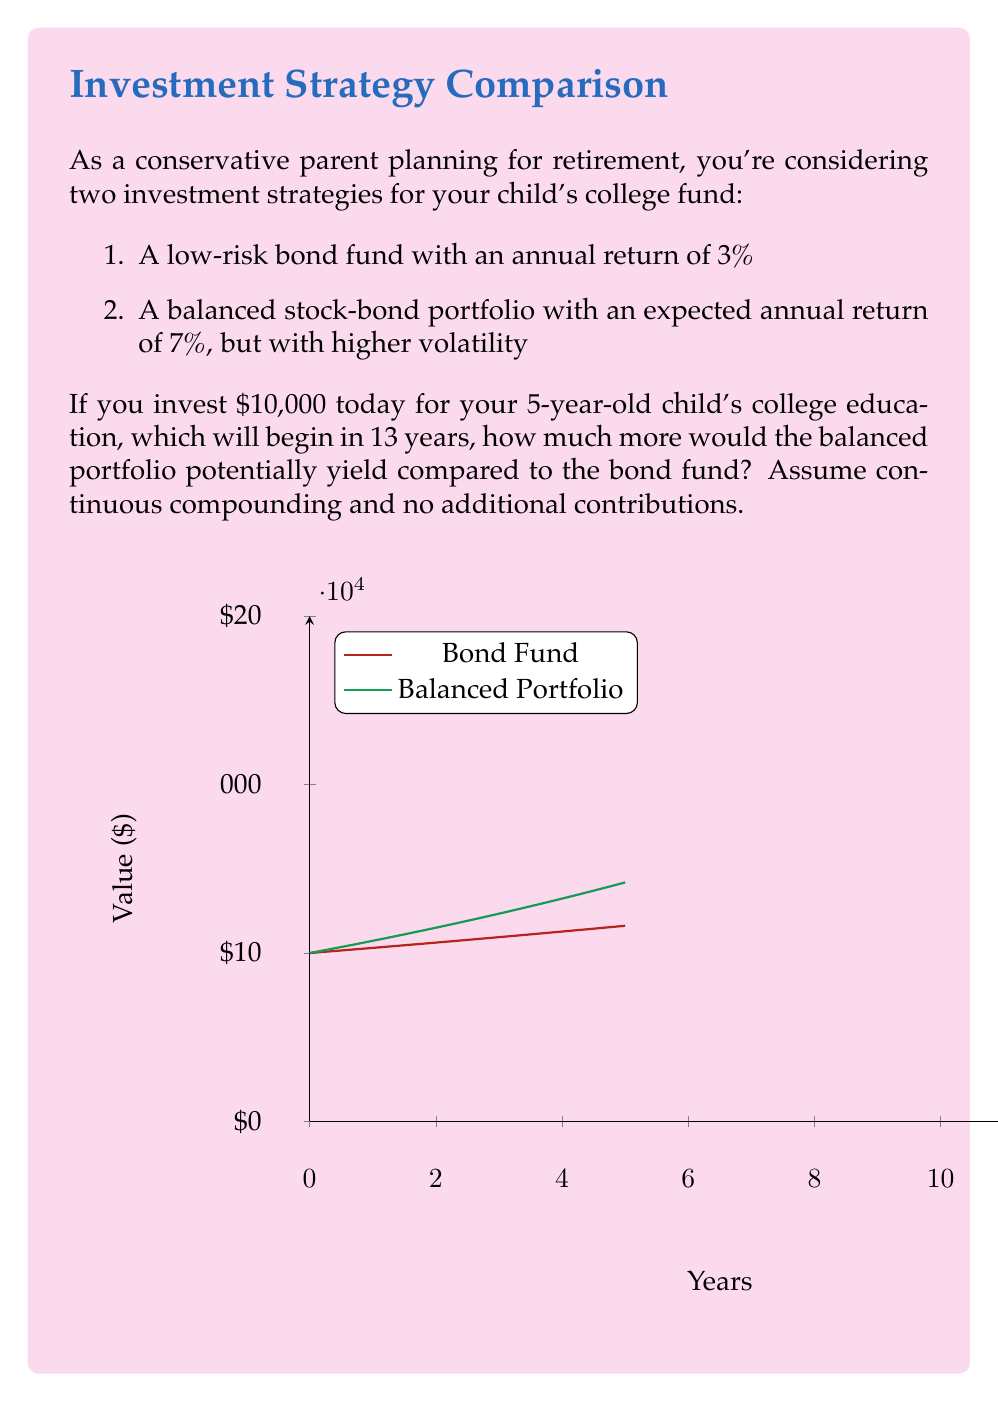Give your solution to this math problem. Let's approach this step-by-step:

1) For continuous compounding, we use the formula:
   $A = P \cdot e^{rt}$
   Where:
   $A$ = final amount
   $P$ = principal (initial investment)
   $r$ = annual interest rate (as a decimal)
   $t$ = time in years
   $e$ = Euler's number (approximately 2.71828)

2) For the bond fund (3% return):
   $A_1 = 10000 \cdot e^{0.03 \cdot 13}$
   $A_1 = 10000 \cdot e^{0.39}$
   $A_1 = 10000 \cdot 1.4770$
   $A_1 = 14,770$

3) For the balanced portfolio (7% return):
   $A_2 = 10000 \cdot e^{0.07 \cdot 13}$
   $A_2 = 10000 \cdot e^{0.91}$
   $A_2 = 10000 \cdot 2.4843$
   $A_2 = 24,843$

4) The difference between the two outcomes:
   $\text{Difference} = A_2 - A_1$
   $\text{Difference} = 24,843 - 14,770$
   $\text{Difference} = 10,073$

Therefore, the balanced portfolio would potentially yield $10,073 more than the bond fund after 13 years.
Answer: $10,073 